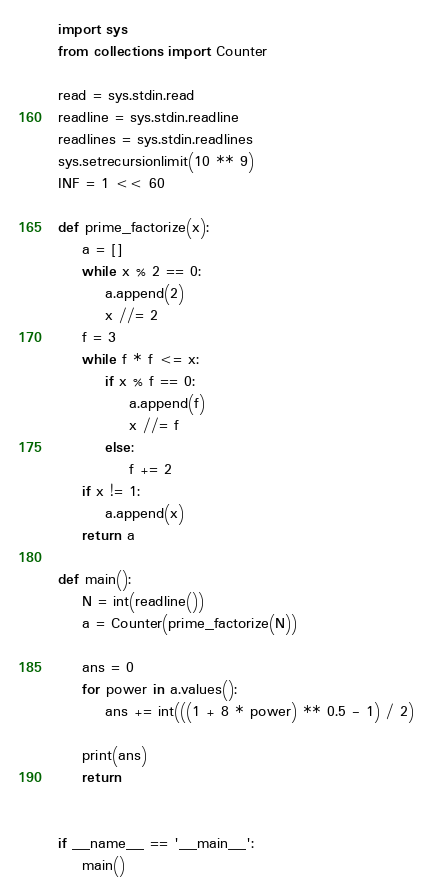Convert code to text. <code><loc_0><loc_0><loc_500><loc_500><_Python_>import sys
from collections import Counter
 
read = sys.stdin.read
readline = sys.stdin.readline
readlines = sys.stdin.readlines
sys.setrecursionlimit(10 ** 9)
INF = 1 << 60

def prime_factorize(x):
    a = []
    while x % 2 == 0:
        a.append(2)
        x //= 2
    f = 3
    while f * f <= x:
        if x % f == 0:
            a.append(f)
            x //= f
        else:
            f += 2
    if x != 1:
        a.append(x)
    return a

def main():
    N = int(readline())
    a = Counter(prime_factorize(N))
 
    ans = 0
    for power in a.values():
        ans += int(((1 + 8 * power) ** 0.5 - 1) / 2)
 
    print(ans)
    return
 
 
if __name__ == '__main__':
    main()</code> 